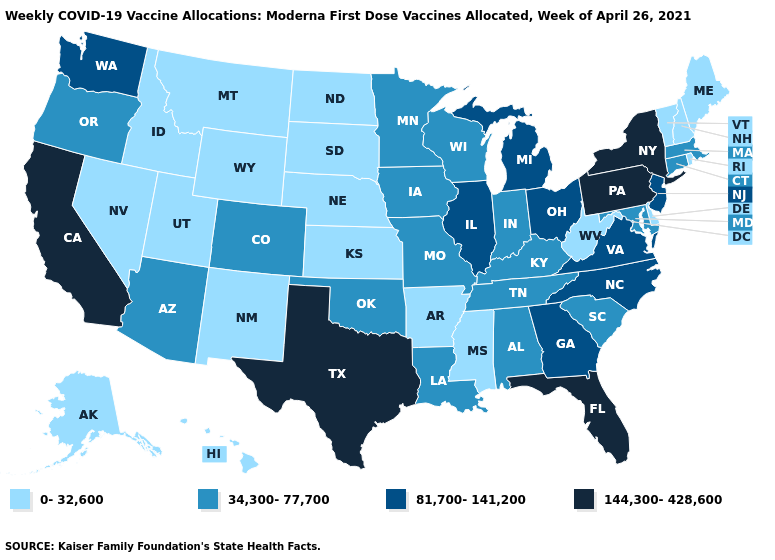What is the highest value in the USA?
Quick response, please. 144,300-428,600. What is the highest value in the USA?
Keep it brief. 144,300-428,600. Among the states that border Oklahoma , which have the highest value?
Give a very brief answer. Texas. Name the states that have a value in the range 81,700-141,200?
Give a very brief answer. Georgia, Illinois, Michigan, New Jersey, North Carolina, Ohio, Virginia, Washington. Name the states that have a value in the range 144,300-428,600?
Concise answer only. California, Florida, New York, Pennsylvania, Texas. Does California have the highest value in the West?
Give a very brief answer. Yes. Does Alabama have a lower value than Florida?
Answer briefly. Yes. Name the states that have a value in the range 0-32,600?
Concise answer only. Alaska, Arkansas, Delaware, Hawaii, Idaho, Kansas, Maine, Mississippi, Montana, Nebraska, Nevada, New Hampshire, New Mexico, North Dakota, Rhode Island, South Dakota, Utah, Vermont, West Virginia, Wyoming. Name the states that have a value in the range 0-32,600?
Give a very brief answer. Alaska, Arkansas, Delaware, Hawaii, Idaho, Kansas, Maine, Mississippi, Montana, Nebraska, Nevada, New Hampshire, New Mexico, North Dakota, Rhode Island, South Dakota, Utah, Vermont, West Virginia, Wyoming. Does Texas have the same value as California?
Give a very brief answer. Yes. What is the value of Alabama?
Be succinct. 34,300-77,700. What is the highest value in states that border Pennsylvania?
Be succinct. 144,300-428,600. What is the lowest value in the USA?
Write a very short answer. 0-32,600. Does Illinois have the same value as New Jersey?
Short answer required. Yes. What is the value of Minnesota?
Short answer required. 34,300-77,700. 